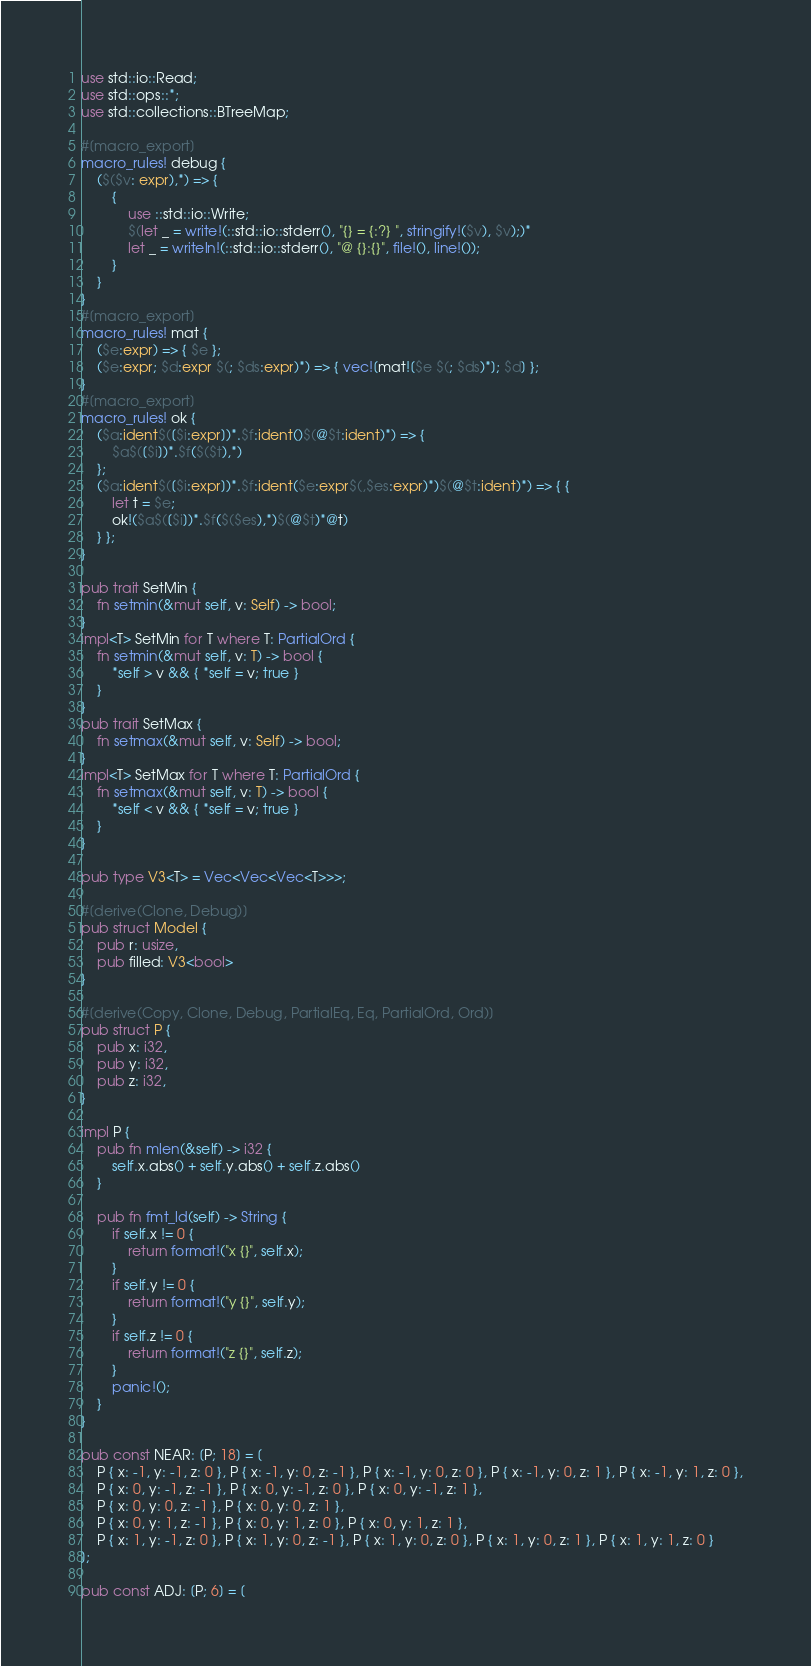<code> <loc_0><loc_0><loc_500><loc_500><_Rust_>use std::io::Read;
use std::ops::*;
use std::collections::BTreeMap;

#[macro_export]
macro_rules! debug {
	($($v: expr),*) => {
		{
			use ::std::io::Write;
			$(let _ = write!(::std::io::stderr(), "{} = {:?} ", stringify!($v), $v);)*
			let _ = writeln!(::std::io::stderr(), "@ {}:{}", file!(), line!());
		}
	}
}
#[macro_export]
macro_rules! mat {
	($e:expr) => { $e };
	($e:expr; $d:expr $(; $ds:expr)*) => { vec![mat![$e $(; $ds)*]; $d] };
}
#[macro_export]
macro_rules! ok {
	($a:ident$([$i:expr])*.$f:ident()$(@$t:ident)*) => {
		$a$([$i])*.$f($($t),*)
	};
	($a:ident$([$i:expr])*.$f:ident($e:expr$(,$es:expr)*)$(@$t:ident)*) => { {
		let t = $e;
		ok!($a$([$i])*.$f($($es),*)$(@$t)*@t)
	} };
}

pub trait SetMin {
	fn setmin(&mut self, v: Self) -> bool;
}
impl<T> SetMin for T where T: PartialOrd {
	fn setmin(&mut self, v: T) -> bool {
		*self > v && { *self = v; true }
	}
}
pub trait SetMax {
	fn setmax(&mut self, v: Self) -> bool;
}
impl<T> SetMax for T where T: PartialOrd {
	fn setmax(&mut self, v: T) -> bool {
		*self < v && { *self = v; true }
	}
}

pub type V3<T> = Vec<Vec<Vec<T>>>;

#[derive(Clone, Debug)]
pub struct Model {
	pub r: usize,
	pub filled: V3<bool>
}

#[derive(Copy, Clone, Debug, PartialEq, Eq, PartialOrd, Ord)]
pub struct P {
	pub x: i32,
	pub y: i32,
	pub z: i32,
}

impl P {
	pub fn mlen(&self) -> i32 {
		self.x.abs() + self.y.abs() + self.z.abs()
	}

    pub fn fmt_ld(self) -> String {
        if self.x != 0 {
            return format!("x {}", self.x);
        }
        if self.y != 0 {
            return format!("y {}", self.y);
        }
        if self.z != 0 {
            return format!("z {}", self.z);
        }
        panic!();
    }
}

pub const NEAR: [P; 18] = [
	P { x: -1, y: -1, z: 0 }, P { x: -1, y: 0, z: -1 }, P { x: -1, y: 0, z: 0 }, P { x: -1, y: 0, z: 1 }, P { x: -1, y: 1, z: 0 },
	P { x: 0, y: -1, z: -1 }, P { x: 0, y: -1, z: 0 }, P { x: 0, y: -1, z: 1 },
	P { x: 0, y: 0, z: -1 }, P { x: 0, y: 0, z: 1 },
	P { x: 0, y: 1, z: -1 }, P { x: 0, y: 1, z: 0 }, P { x: 0, y: 1, z: 1 },
	P { x: 1, y: -1, z: 0 }, P { x: 1, y: 0, z: -1 }, P { x: 1, y: 0, z: 0 }, P { x: 1, y: 0, z: 1 }, P { x: 1, y: 1, z: 0 }
];

pub const ADJ: [P; 6] = [</code> 